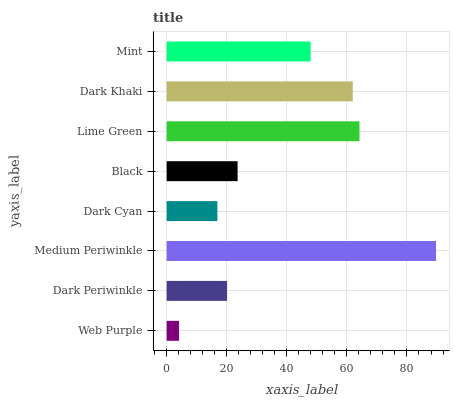Is Web Purple the minimum?
Answer yes or no. Yes. Is Medium Periwinkle the maximum?
Answer yes or no. Yes. Is Dark Periwinkle the minimum?
Answer yes or no. No. Is Dark Periwinkle the maximum?
Answer yes or no. No. Is Dark Periwinkle greater than Web Purple?
Answer yes or no. Yes. Is Web Purple less than Dark Periwinkle?
Answer yes or no. Yes. Is Web Purple greater than Dark Periwinkle?
Answer yes or no. No. Is Dark Periwinkle less than Web Purple?
Answer yes or no. No. Is Mint the high median?
Answer yes or no. Yes. Is Black the low median?
Answer yes or no. Yes. Is Lime Green the high median?
Answer yes or no. No. Is Web Purple the low median?
Answer yes or no. No. 